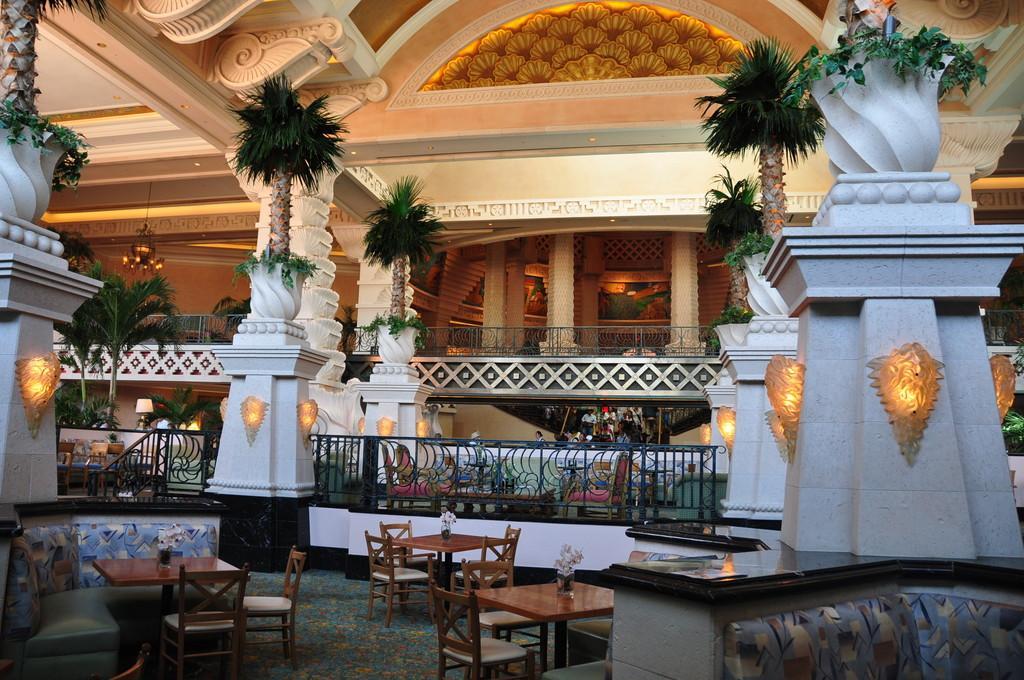Could you give a brief overview of what you see in this image? In the image we can see there is a huge building in which there are tables and chairs and trees. 